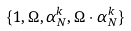<formula> <loc_0><loc_0><loc_500><loc_500>\{ { 1 } , \Omega , \alpha ^ { k } _ { N } , \Omega \cdot \alpha ^ { k } _ { N } \}</formula> 